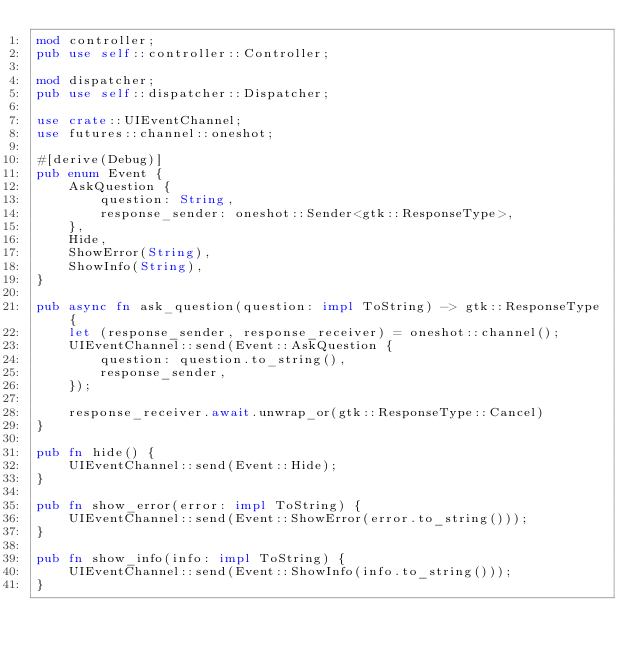Convert code to text. <code><loc_0><loc_0><loc_500><loc_500><_Rust_>mod controller;
pub use self::controller::Controller;

mod dispatcher;
pub use self::dispatcher::Dispatcher;

use crate::UIEventChannel;
use futures::channel::oneshot;

#[derive(Debug)]
pub enum Event {
    AskQuestion {
        question: String,
        response_sender: oneshot::Sender<gtk::ResponseType>,
    },
    Hide,
    ShowError(String),
    ShowInfo(String),
}

pub async fn ask_question(question: impl ToString) -> gtk::ResponseType {
    let (response_sender, response_receiver) = oneshot::channel();
    UIEventChannel::send(Event::AskQuestion {
        question: question.to_string(),
        response_sender,
    });

    response_receiver.await.unwrap_or(gtk::ResponseType::Cancel)
}

pub fn hide() {
    UIEventChannel::send(Event::Hide);
}

pub fn show_error(error: impl ToString) {
    UIEventChannel::send(Event::ShowError(error.to_string()));
}

pub fn show_info(info: impl ToString) {
    UIEventChannel::send(Event::ShowInfo(info.to_string()));
}
</code> 